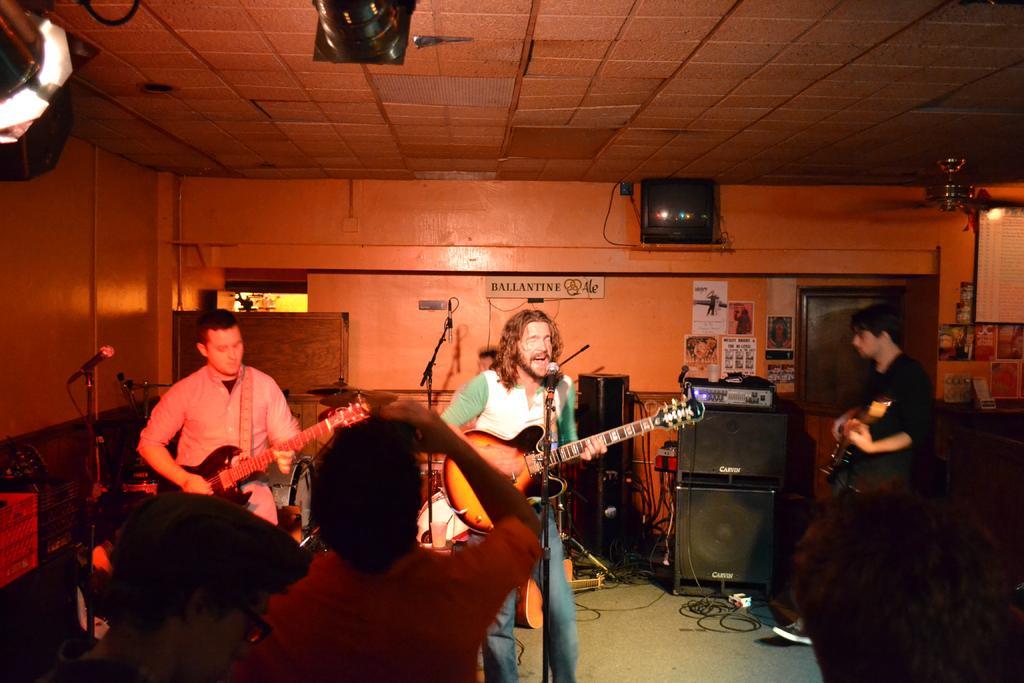Please provide a concise description of this image. In this picture there are three men standing and the men with pink shirt is standing and playing guitar. And the men in the middle with white and green t-shirt is standing and playing guitar. In front of him there is a mic. To the right side there is a man with black t-shirt and standing and playing guitar. In the front of them there are three people standing. And there some speakers,black boxes and mics. And in the background there is a wall in the orange color and some posters. 